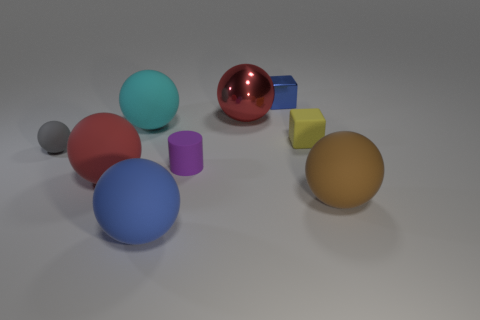Subtract all large shiny spheres. How many spheres are left? 5 Subtract all red balls. How many balls are left? 4 Subtract 2 spheres. How many spheres are left? 4 Subtract all cyan spheres. Subtract all green cylinders. How many spheres are left? 5 Subtract all cylinders. How many objects are left? 8 Add 7 big yellow metal cubes. How many big yellow metal cubes exist? 7 Subtract 1 blue balls. How many objects are left? 8 Subtract all big things. Subtract all metallic objects. How many objects are left? 2 Add 2 small gray spheres. How many small gray spheres are left? 3 